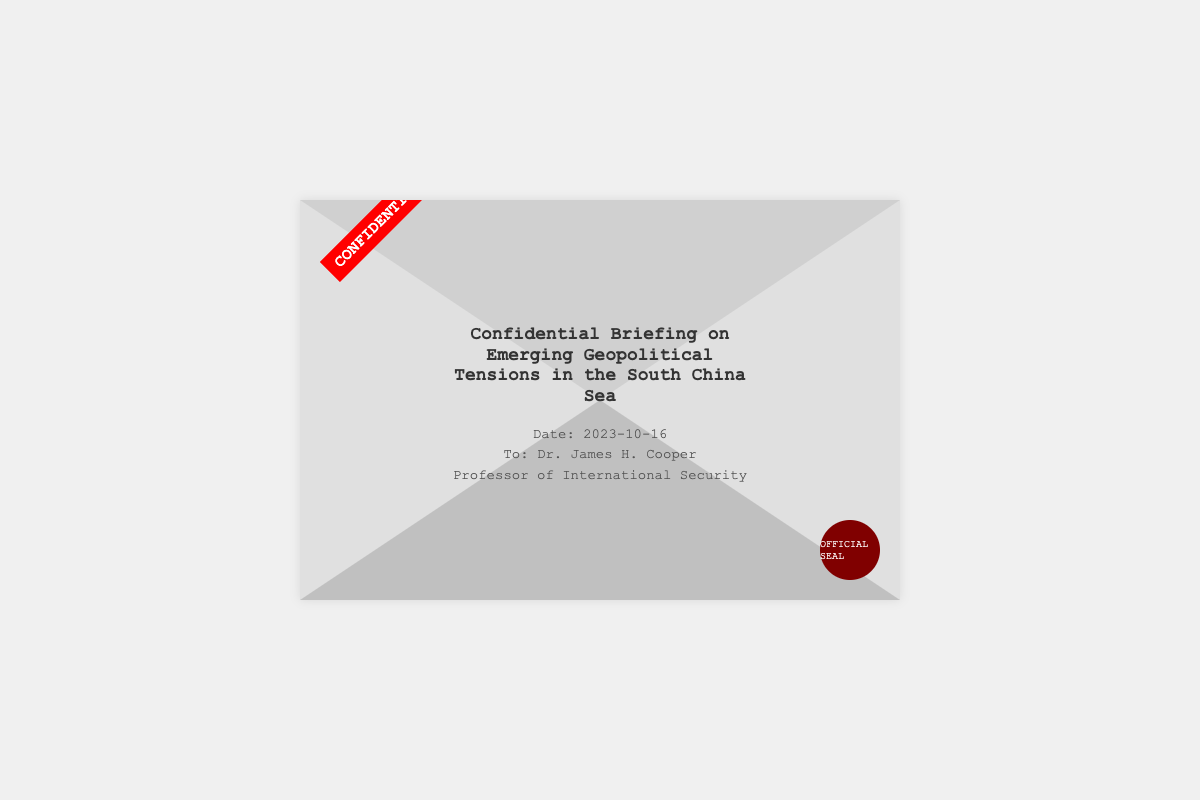what is the title of the briefing? The title is clearly stated in the document.
Answer: Confidential Briefing on Emerging Geopolitical Tensions in the South China Sea who is the recipient of the briefing? The document specifies the person to whom the briefing is addressed.
Answer: Dr. James H. Cooper what is the date of the briefing? The date is mentioned prominently within the content of the document.
Answer: 2023-10-16 what is the profession of the recipient? The document includes a description of the recipient's professional title.
Answer: Professor of International Security what type of document is presented? The format of the document indicates its nature distinctly.
Answer: Confidential Briefing what color is the seal in the document? The seal's description provides details about its appearance.
Answer: Dark red what is the background color of the envelope? The color of the envelope is specified in the visual style of the document.
Answer: Light gray where is the "CONFIDENTIAL" label positioned? The positioning of the label is noted in the document layout.
Answer: Top left corner how many names are mentioned in the document? The document explicitly states the number of individuals mentioned.
Answer: One 